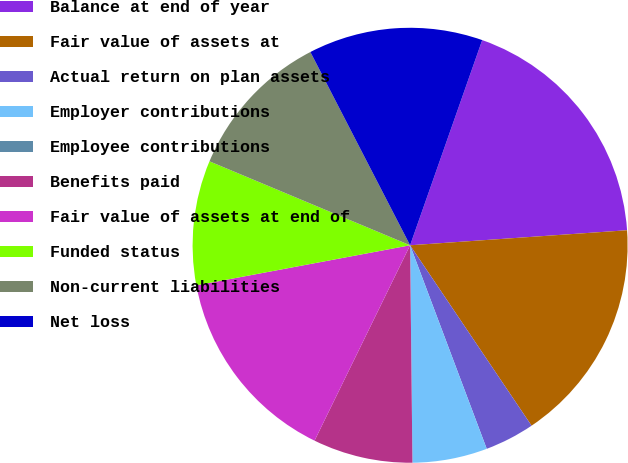<chart> <loc_0><loc_0><loc_500><loc_500><pie_chart><fcel>Balance at end of year<fcel>Fair value of assets at<fcel>Actual return on plan assets<fcel>Employer contributions<fcel>Employee contributions<fcel>Benefits paid<fcel>Fair value of assets at end of<fcel>Funded status<fcel>Non-current liabilities<fcel>Net loss<nl><fcel>18.52%<fcel>16.67%<fcel>3.7%<fcel>5.56%<fcel>0.0%<fcel>7.41%<fcel>14.81%<fcel>9.26%<fcel>11.11%<fcel>12.96%<nl></chart> 